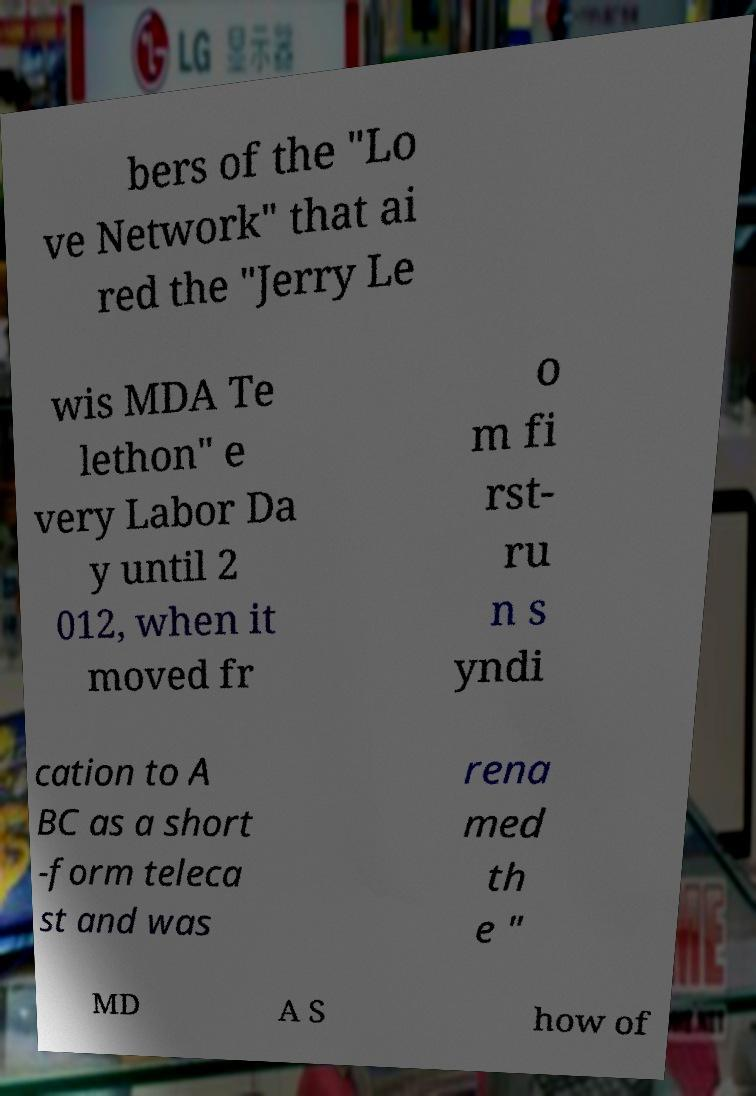Please read and relay the text visible in this image. What does it say? bers of the "Lo ve Network" that ai red the "Jerry Le wis MDA Te lethon" e very Labor Da y until 2 012, when it moved fr o m fi rst- ru n s yndi cation to A BC as a short -form teleca st and was rena med th e " MD A S how of 